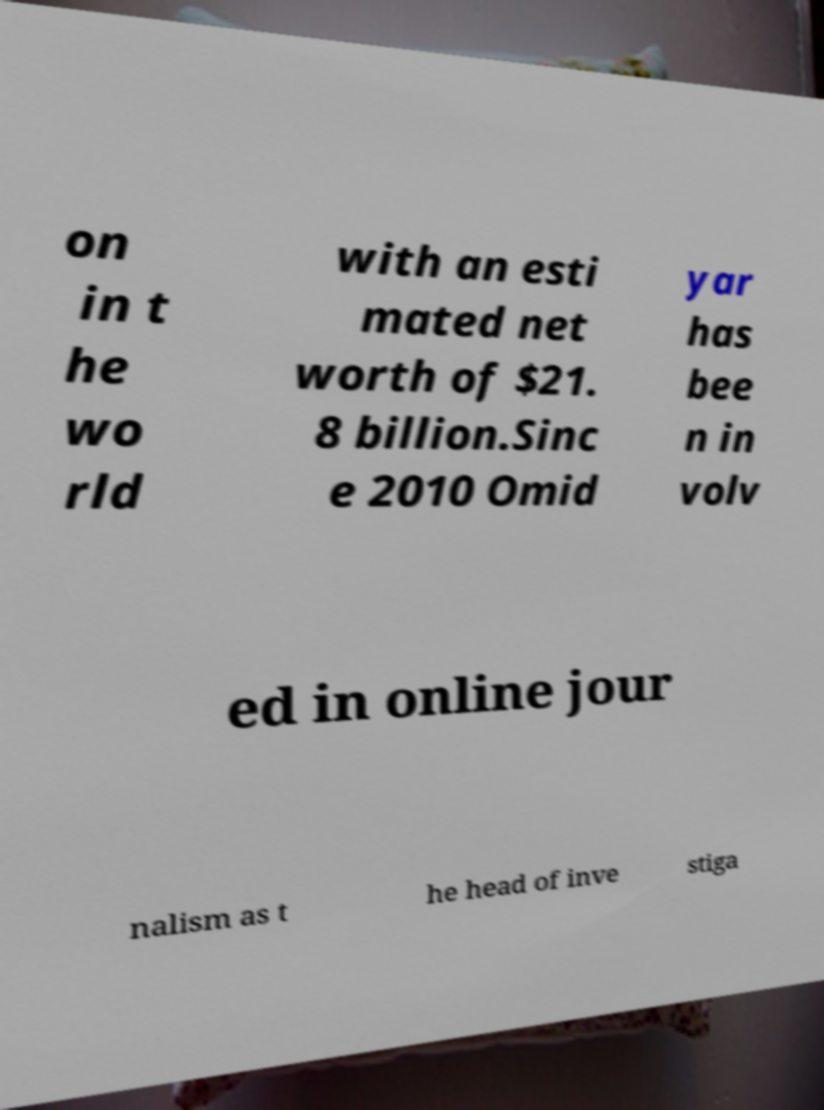Can you read and provide the text displayed in the image?This photo seems to have some interesting text. Can you extract and type it out for me? on in t he wo rld with an esti mated net worth of $21. 8 billion.Sinc e 2010 Omid yar has bee n in volv ed in online jour nalism as t he head of inve stiga 